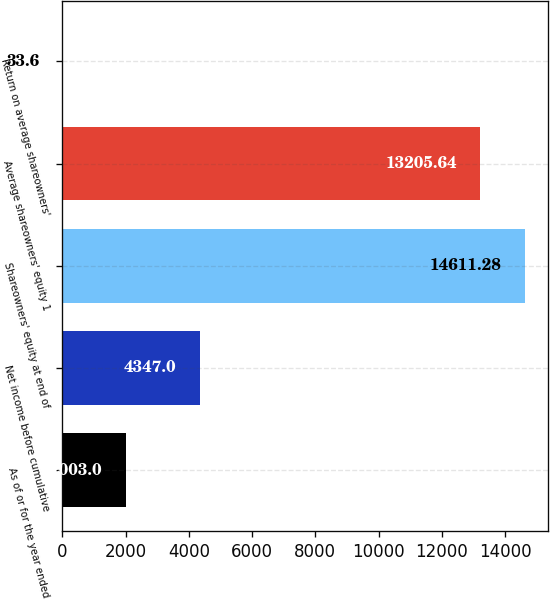Convert chart to OTSL. <chart><loc_0><loc_0><loc_500><loc_500><bar_chart><fcel>As of or for the year ended<fcel>Net income before cumulative<fcel>Shareowners' equity at end of<fcel>Average shareowners' equity 1<fcel>Return on average shareowners'<nl><fcel>2003<fcel>4347<fcel>14611.3<fcel>13205.6<fcel>33.6<nl></chart> 